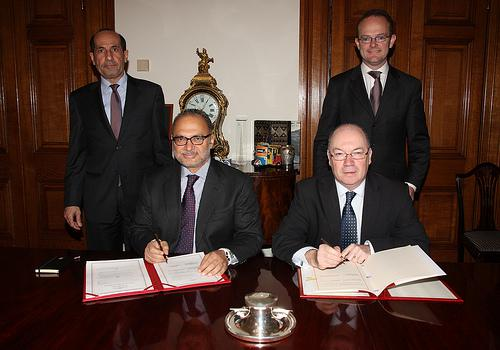Question: what are the nearest men doing?
Choices:
A. Running.
B. Walking.
C. Sitting.
D. Laughing.
Answer with the letter. Answer: C Question: how many men?
Choices:
A. One.
B. Two.
C. Four.
D. Three.
Answer with the letter. Answer: C Question: who is wearing a purple tie?
Choices:
A. Man on the left.
B. Man in the middle.
C. Man sitting in right.
D. The boy.
Answer with the letter. Answer: C Question: where are the notebooks?
Choices:
A. On the table.
B. On the desk.
C. On the counter.
D. In the back pack.
Answer with the letter. Answer: A 